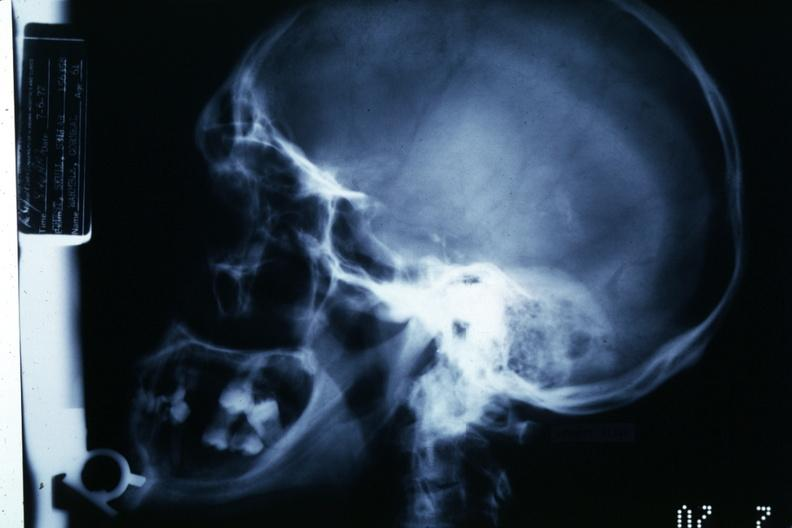does this image show x-ray showing large sella turcica?
Answer the question using a single word or phrase. Yes 